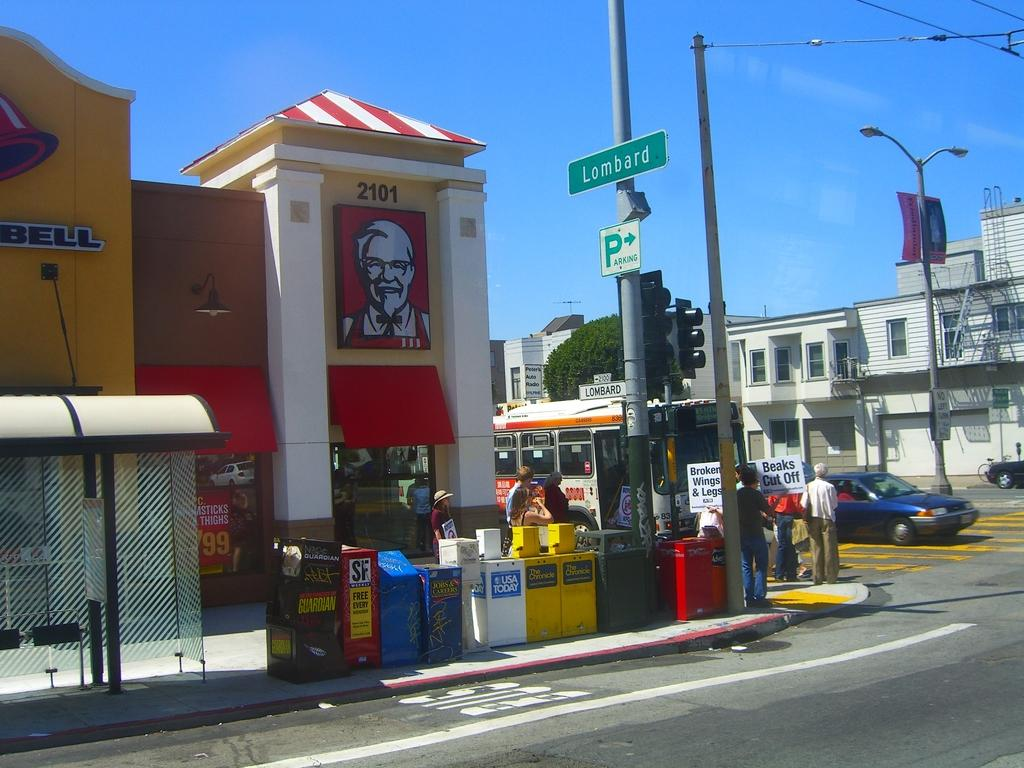What is located in the center of the image? There are boxes with posters in the center of the image. What can be seen in the background of the image? The sky, buildings, poles, vehicles, and people are visible in the background of the image. Are there any other objects present in the background of the image? Yes, there are other unspecified objects in the background of the image. What type of card is being used by the kitten in the image? There is no kitten or card present in the image. What action are the people in the background of the image performing? The provided facts do not specify any actions being performed by the people in the background of the image. 